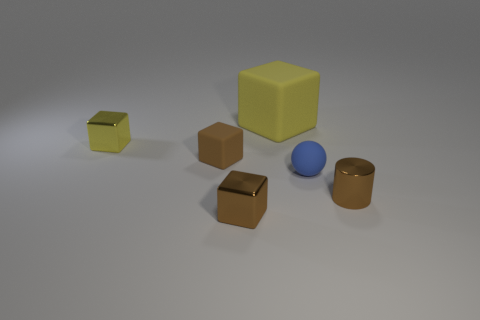There is a small matte thing that is to the right of the small shiny block that is to the right of the tiny metallic block that is behind the blue sphere; what shape is it?
Offer a terse response. Sphere. How many other objects are the same shape as the small brown matte thing?
Offer a very short reply. 3. There is a cylinder; does it have the same color as the small metal cube in front of the tiny blue matte thing?
Ensure brevity in your answer.  Yes. What number of brown cylinders are there?
Ensure brevity in your answer.  1. How many objects are small blue rubber things or metallic cylinders?
Your response must be concise. 2. The shiny thing that is the same color as the metal cylinder is what size?
Provide a short and direct response. Small. Are there any small metal things to the left of the brown matte object?
Provide a short and direct response. Yes. Is the number of small rubber things on the left side of the yellow matte cube greater than the number of yellow rubber things that are on the right side of the brown cylinder?
Offer a very short reply. Yes. The brown metallic thing that is the same shape as the brown matte thing is what size?
Keep it short and to the point. Small. What number of blocks are either small brown things or large cyan things?
Offer a very short reply. 2. 